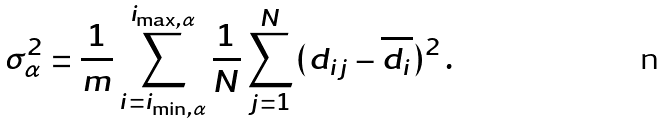<formula> <loc_0><loc_0><loc_500><loc_500>\sigma _ { \alpha } ^ { 2 } = \frac { 1 } { m } \sum _ { i = i _ { \min , \alpha } } ^ { i _ { \max , \alpha } } \frac { 1 } { N } \sum _ { j = 1 } ^ { N } ( d _ { i j } - \overline { d _ { i } } ) ^ { 2 } \, .</formula> 